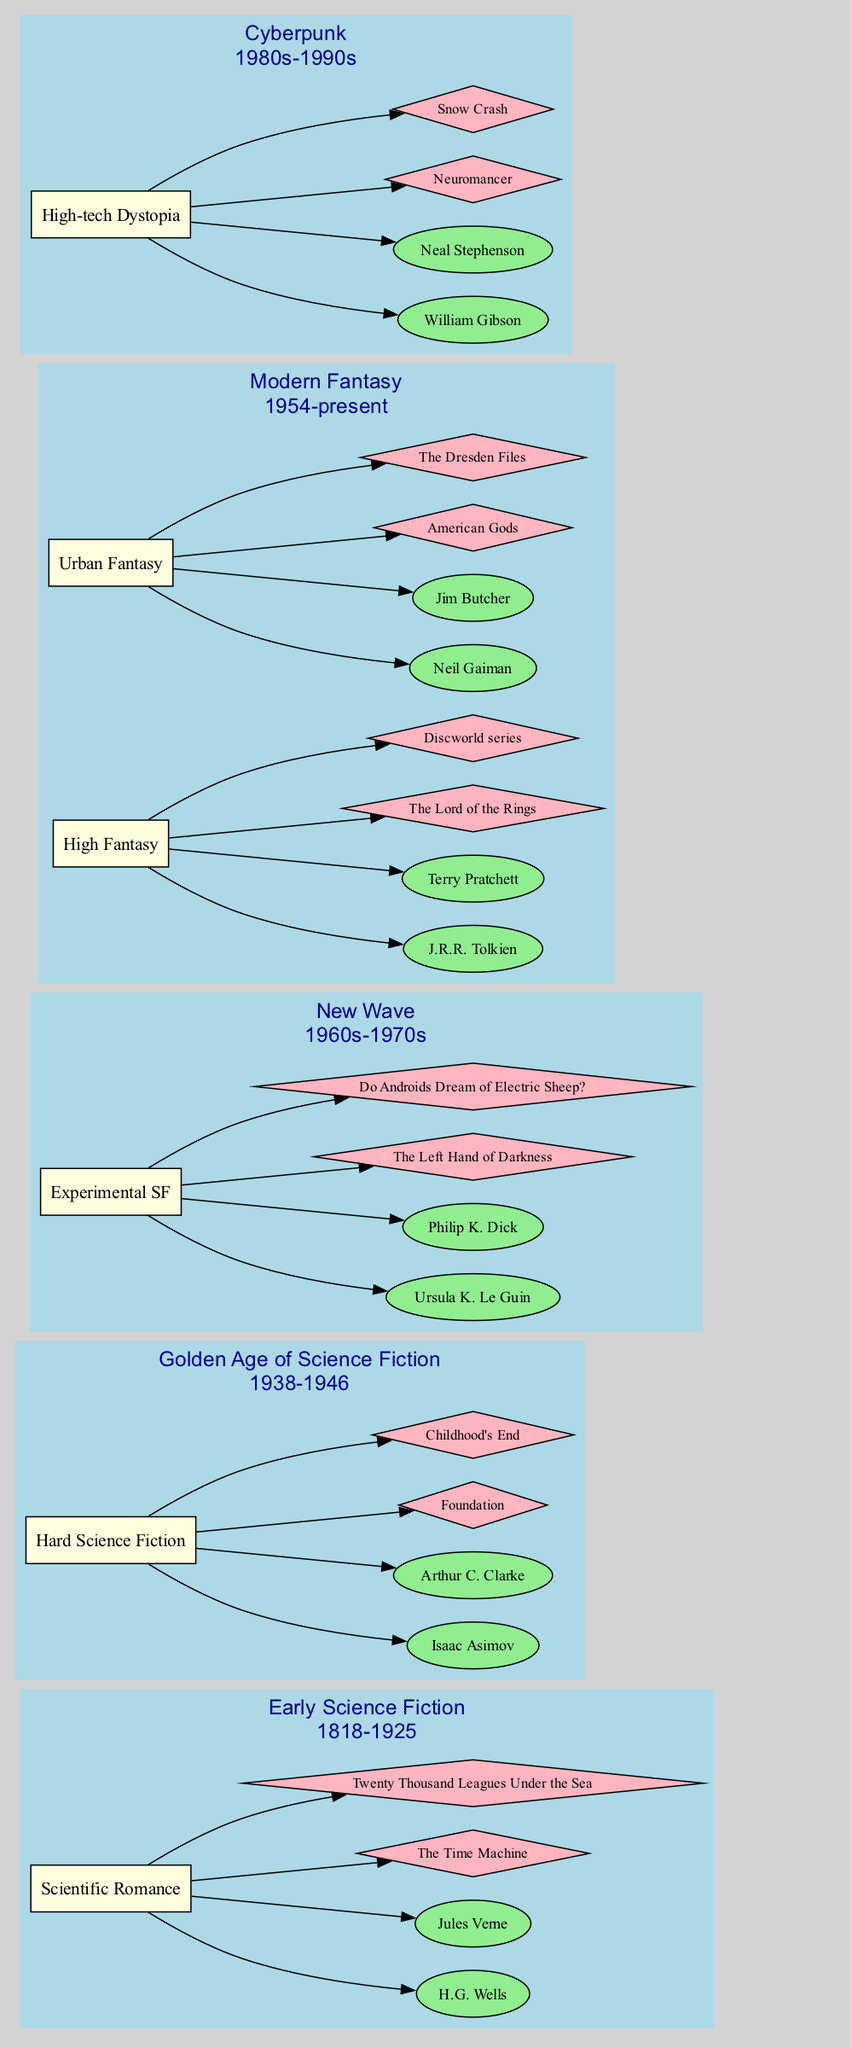What is the period of the Golden Age of Science Fiction? The diagram explicitly states that the Golden Age of Science Fiction covers the period from 1938 to 1946. This information is directly linked to the label of the respective era on the diagram.
Answer: 1938-1946 Which author is associated with the work "The Left Hand of Darkness"? The diagram connects the work "The Left Hand of Darkness" to the movement of Experimental SF under the New Wave era. Within that movement, Ursula K. Le Guin is listed as an author, indicating her association with that work.
Answer: Ursula K. Le Guin How many movements are present in the Modern Fantasy era? The diagram clearly illustrates that the Modern Fantasy era is broken down into two distinct movements, High Fantasy and Urban Fantasy. Thus, by counting these movements, we find the answer.
Answer: 2 Which era features High-tech Dystopia as a movement? In the diagram, High-tech Dystopia is categorized under the Cyberpunk era, which is highlighted distinctly. By following the connections to movements in that era, we arrive at this answer.
Answer: Cyberpunk Who are the authors listed under the Hard Science Fiction movement? The diagram denotes two authors connected to the Hard Science Fiction movement: Isaac Asimov and Arthur C. Clarke. The authors are highlighted and linked directly to this specific movement within the Golden Age of Science Fiction era, leading to the answer.
Answer: Isaac Asimov, Arthur C. Clarke What is the first work listed under High Fantasy? The diagram shows that the High Fantasy movement under the Modern Fantasy era lists "The Lord of the Rings" as its first work. This is explicitly indicated in the connections from the movement to the work node.
Answer: The Lord of the Rings How many major literary eras are presented in the timeline? By inspecting the timeline presented in the diagram, we observe five distinct eras: Early Science Fiction, Golden Age of Science Fiction, New Wave, Modern Fantasy, and Cyberpunk. Thus, we can count these to arrive at our answer.
Answer: 5 Which author from the Urban Fantasy movement has written American Gods? The diagram associates "American Gods" with Neil Gaiman within the Urban Fantasy movement in the Modern Fantasy era. This connection can be traced directly from the work node back to the respective author node.
Answer: Neil Gaiman What is the main characteristic of the New Wave movement? The diagram categorizes the New Wave era as being associated with Experimental SF, indicating that the main characteristic of the movement is its focus on experimental elements within science fiction. This is derived from the label directly connected to the movement node.
Answer: Experimental SF 